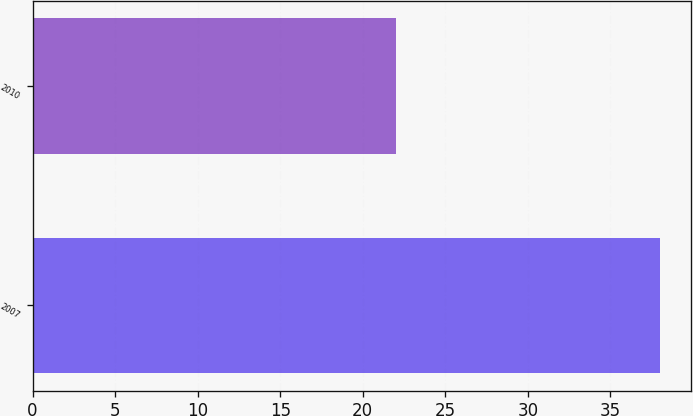Convert chart to OTSL. <chart><loc_0><loc_0><loc_500><loc_500><bar_chart><fcel>2007<fcel>2010<nl><fcel>38<fcel>22<nl></chart> 